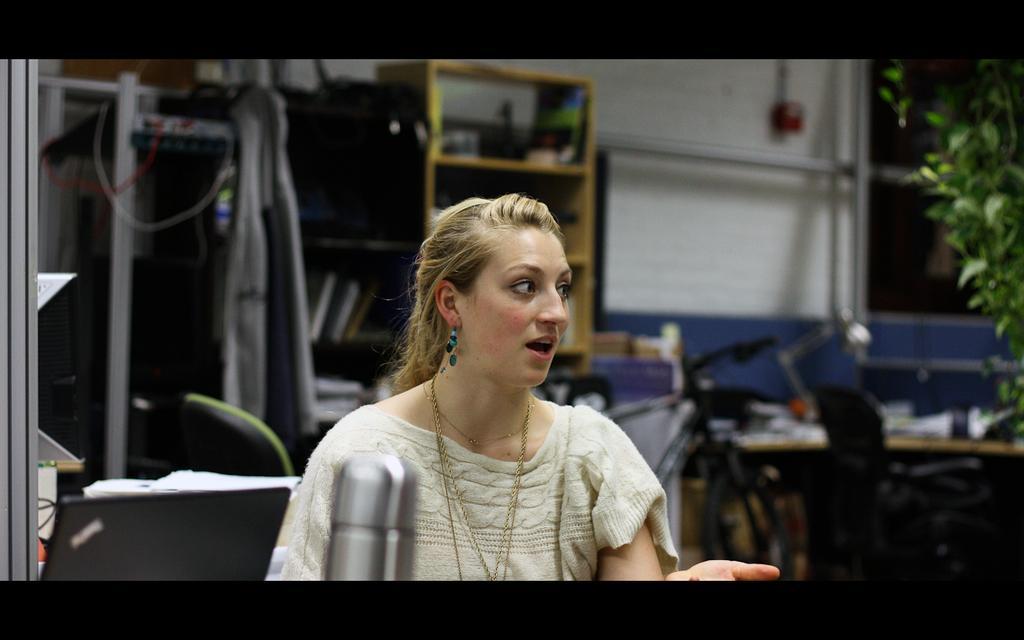In one or two sentences, can you explain what this image depicts? In the picture we can see a woman sitting in the chair and she is with white dress and talking something and behind her we can see some things are placed and beside it we can see a rack in it we can see some things are placed and near to it we can see some plants. 